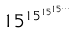<formula> <loc_0><loc_0><loc_500><loc_500>1 5 ^ { 1 5 ^ { 1 5 ^ { 1 5 ^ { \dots } } } }</formula> 